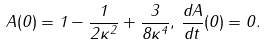Convert formula to latex. <formula><loc_0><loc_0><loc_500><loc_500>A ( 0 ) = 1 - \frac { 1 } { 2 \kappa ^ { 2 } } + \frac { 3 } { 8 \kappa ^ { 4 } } , \, \frac { d A } { d t } ( 0 ) = 0 .</formula> 